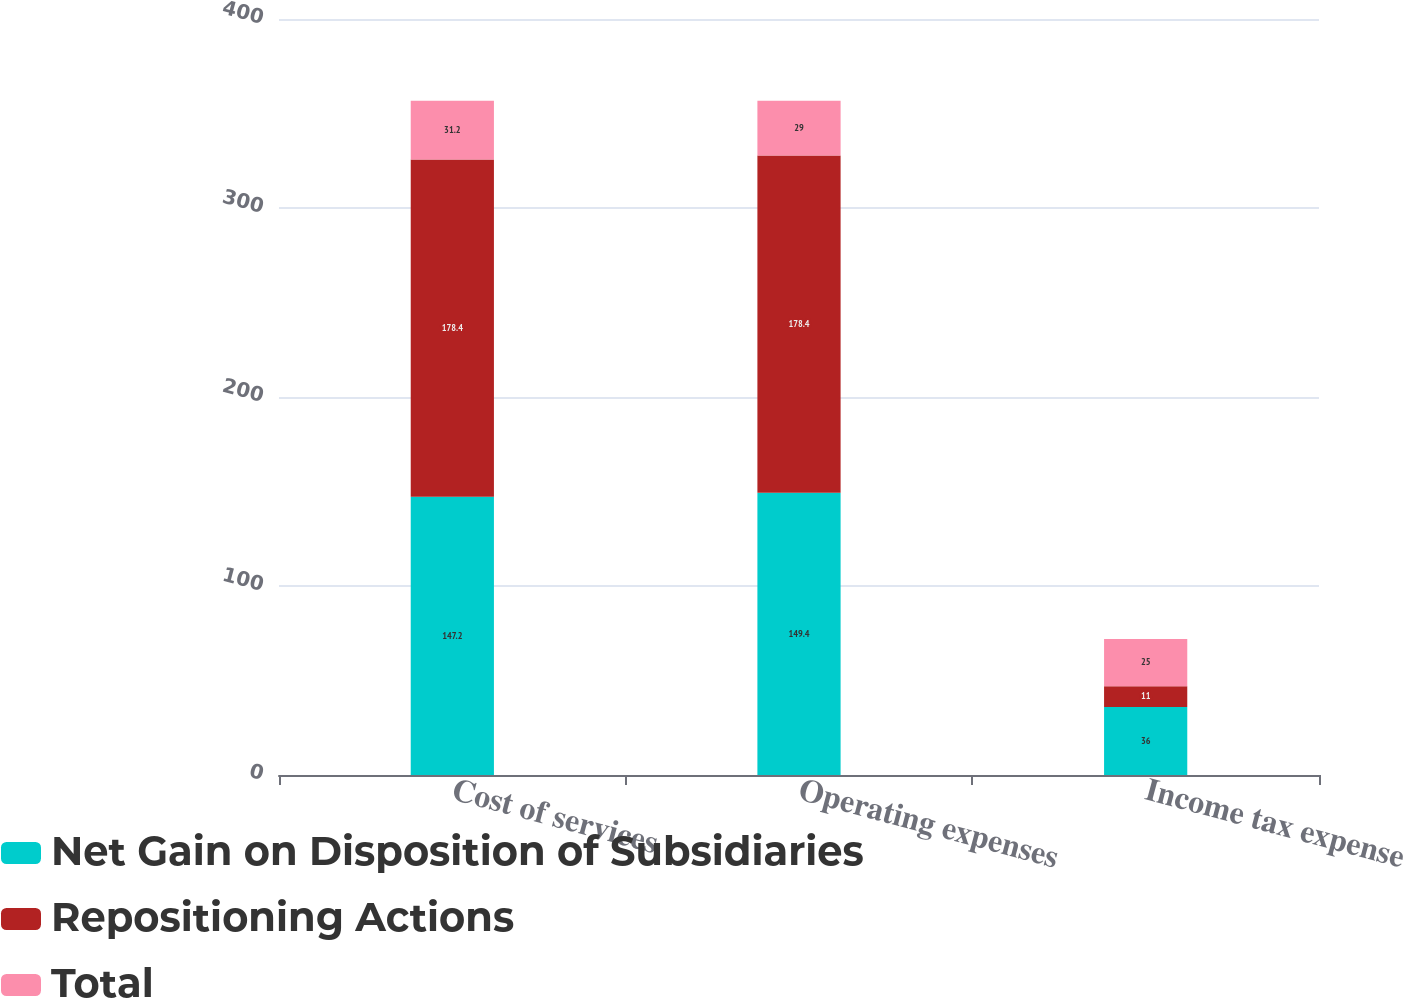Convert chart. <chart><loc_0><loc_0><loc_500><loc_500><stacked_bar_chart><ecel><fcel>Cost of services<fcel>Operating expenses<fcel>Income tax expense<nl><fcel>Net Gain on Disposition of Subsidiaries<fcel>147.2<fcel>149.4<fcel>36<nl><fcel>Repositioning Actions<fcel>178.4<fcel>178.4<fcel>11<nl><fcel>Total<fcel>31.2<fcel>29<fcel>25<nl></chart> 